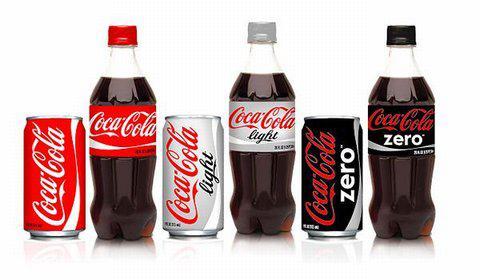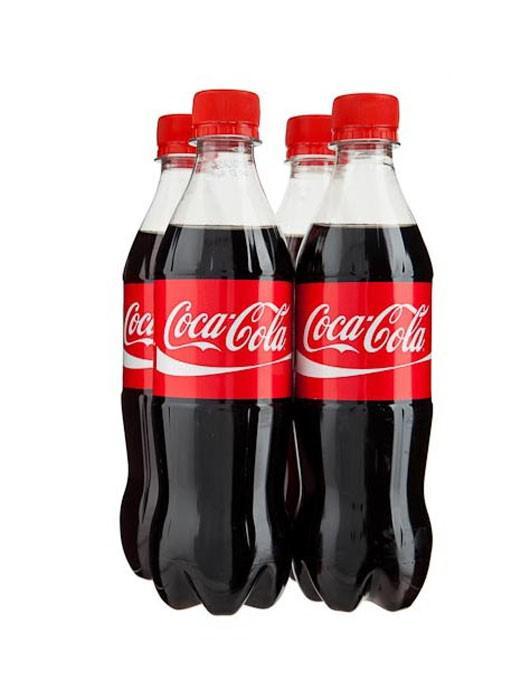The first image is the image on the left, the second image is the image on the right. Assess this claim about the two images: "The left image includes three varieties of one brand of soda in transparent plastic bottles, which are in a row but not touching.". Correct or not? Answer yes or no. Yes. The first image is the image on the left, the second image is the image on the right. Analyze the images presented: Is the assertion "The right image contains at least three bottles." valid? Answer yes or no. Yes. 